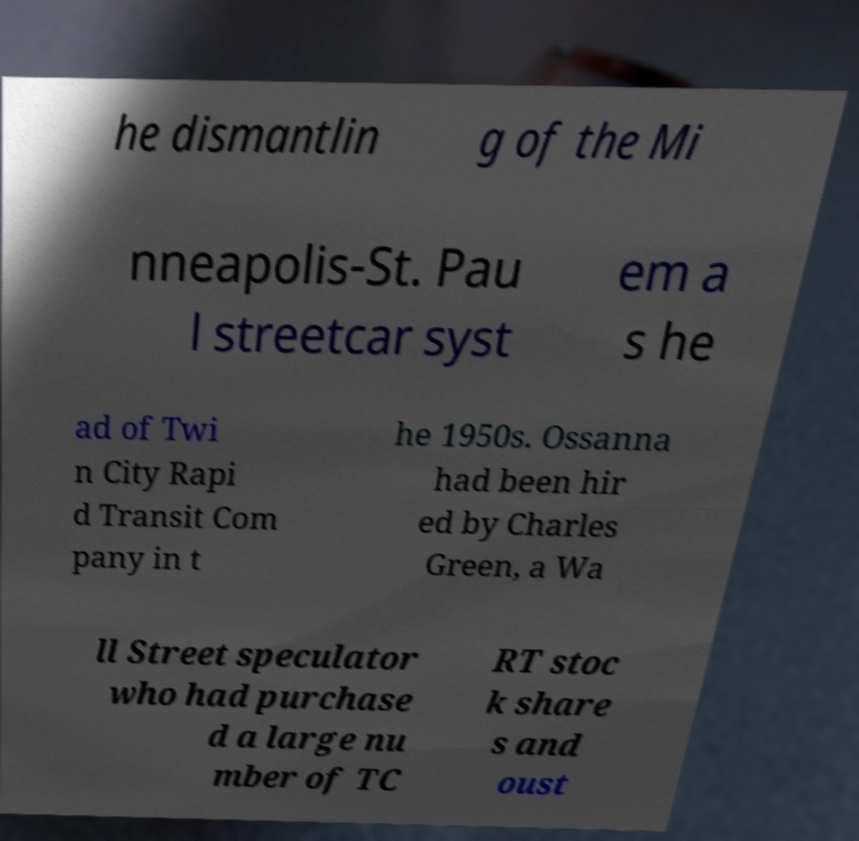Please identify and transcribe the text found in this image. he dismantlin g of the Mi nneapolis-St. Pau l streetcar syst em a s he ad of Twi n City Rapi d Transit Com pany in t he 1950s. Ossanna had been hir ed by Charles Green, a Wa ll Street speculator who had purchase d a large nu mber of TC RT stoc k share s and oust 